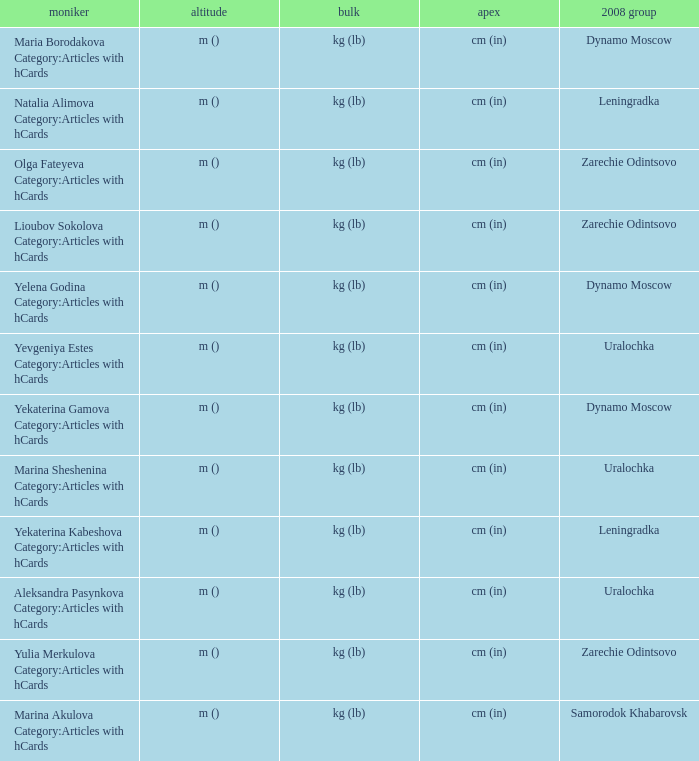What is the name when the 2008 club is uralochka? Yevgeniya Estes Category:Articles with hCards, Marina Sheshenina Category:Articles with hCards, Aleksandra Pasynkova Category:Articles with hCards. Help me parse the entirety of this table. {'header': ['moniker', 'altitude', 'bulk', 'apex', '2008 group'], 'rows': [['Maria Borodakova Category:Articles with hCards', 'm ()', 'kg (lb)', 'cm (in)', 'Dynamo Moscow'], ['Natalia Alimova Category:Articles with hCards', 'm ()', 'kg (lb)', 'cm (in)', 'Leningradka'], ['Olga Fateyeva Category:Articles with hCards', 'm ()', 'kg (lb)', 'cm (in)', 'Zarechie Odintsovo'], ['Lioubov Sokolova Category:Articles with hCards', 'm ()', 'kg (lb)', 'cm (in)', 'Zarechie Odintsovo'], ['Yelena Godina Category:Articles with hCards', 'm ()', 'kg (lb)', 'cm (in)', 'Dynamo Moscow'], ['Yevgeniya Estes Category:Articles with hCards', 'm ()', 'kg (lb)', 'cm (in)', 'Uralochka'], ['Yekaterina Gamova Category:Articles with hCards', 'm ()', 'kg (lb)', 'cm (in)', 'Dynamo Moscow'], ['Marina Sheshenina Category:Articles with hCards', 'm ()', 'kg (lb)', 'cm (in)', 'Uralochka'], ['Yekaterina Kabeshova Category:Articles with hCards', 'm ()', 'kg (lb)', 'cm (in)', 'Leningradka'], ['Aleksandra Pasynkova Category:Articles with hCards', 'm ()', 'kg (lb)', 'cm (in)', 'Uralochka'], ['Yulia Merkulova Category:Articles with hCards', 'm ()', 'kg (lb)', 'cm (in)', 'Zarechie Odintsovo'], ['Marina Akulova Category:Articles with hCards', 'm ()', 'kg (lb)', 'cm (in)', 'Samorodok Khabarovsk']]} 